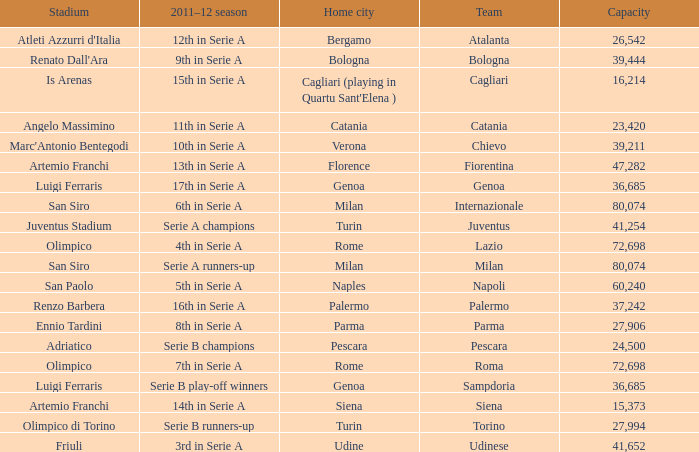What is the home city for angelo massimino stadium? Catania. 